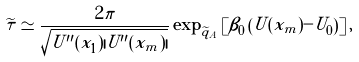<formula> <loc_0><loc_0><loc_500><loc_500>\widetilde { \tau } \simeq \frac { 2 \pi } { \sqrt { U ^ { \prime \prime } ( x _ { 1 } ) | U ^ { \prime \prime } ( x _ { m } ) | } } \exp _ { \widetilde { q } _ { A } } \left [ \beta _ { 0 } \left ( U ( x _ { m } ) - U _ { 0 } \right ) \right ] ,</formula> 